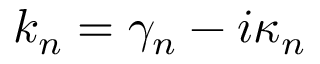<formula> <loc_0><loc_0><loc_500><loc_500>k _ { n } = \gamma _ { n } - i \kappa _ { n }</formula> 